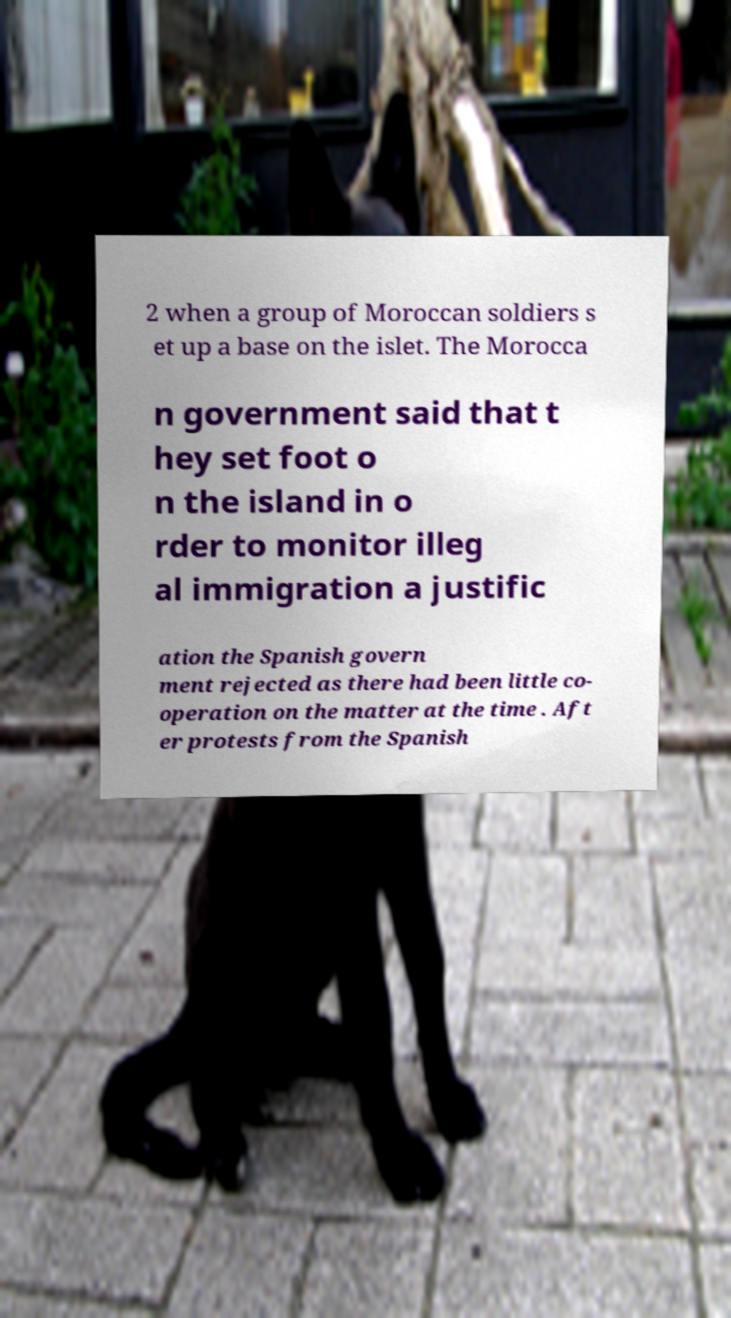What messages or text are displayed in this image? I need them in a readable, typed format. 2 when a group of Moroccan soldiers s et up a base on the islet. The Morocca n government said that t hey set foot o n the island in o rder to monitor illeg al immigration a justific ation the Spanish govern ment rejected as there had been little co- operation on the matter at the time . Aft er protests from the Spanish 